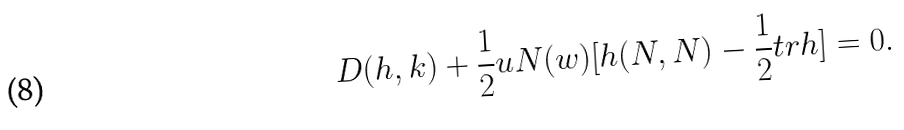<formula> <loc_0><loc_0><loc_500><loc_500>D ( h , k ) + { \frac { 1 } { 2 } } u N ( w ) [ h ( N , N ) - { \frac { 1 } { 2 } } t r h ] = 0 .</formula> 